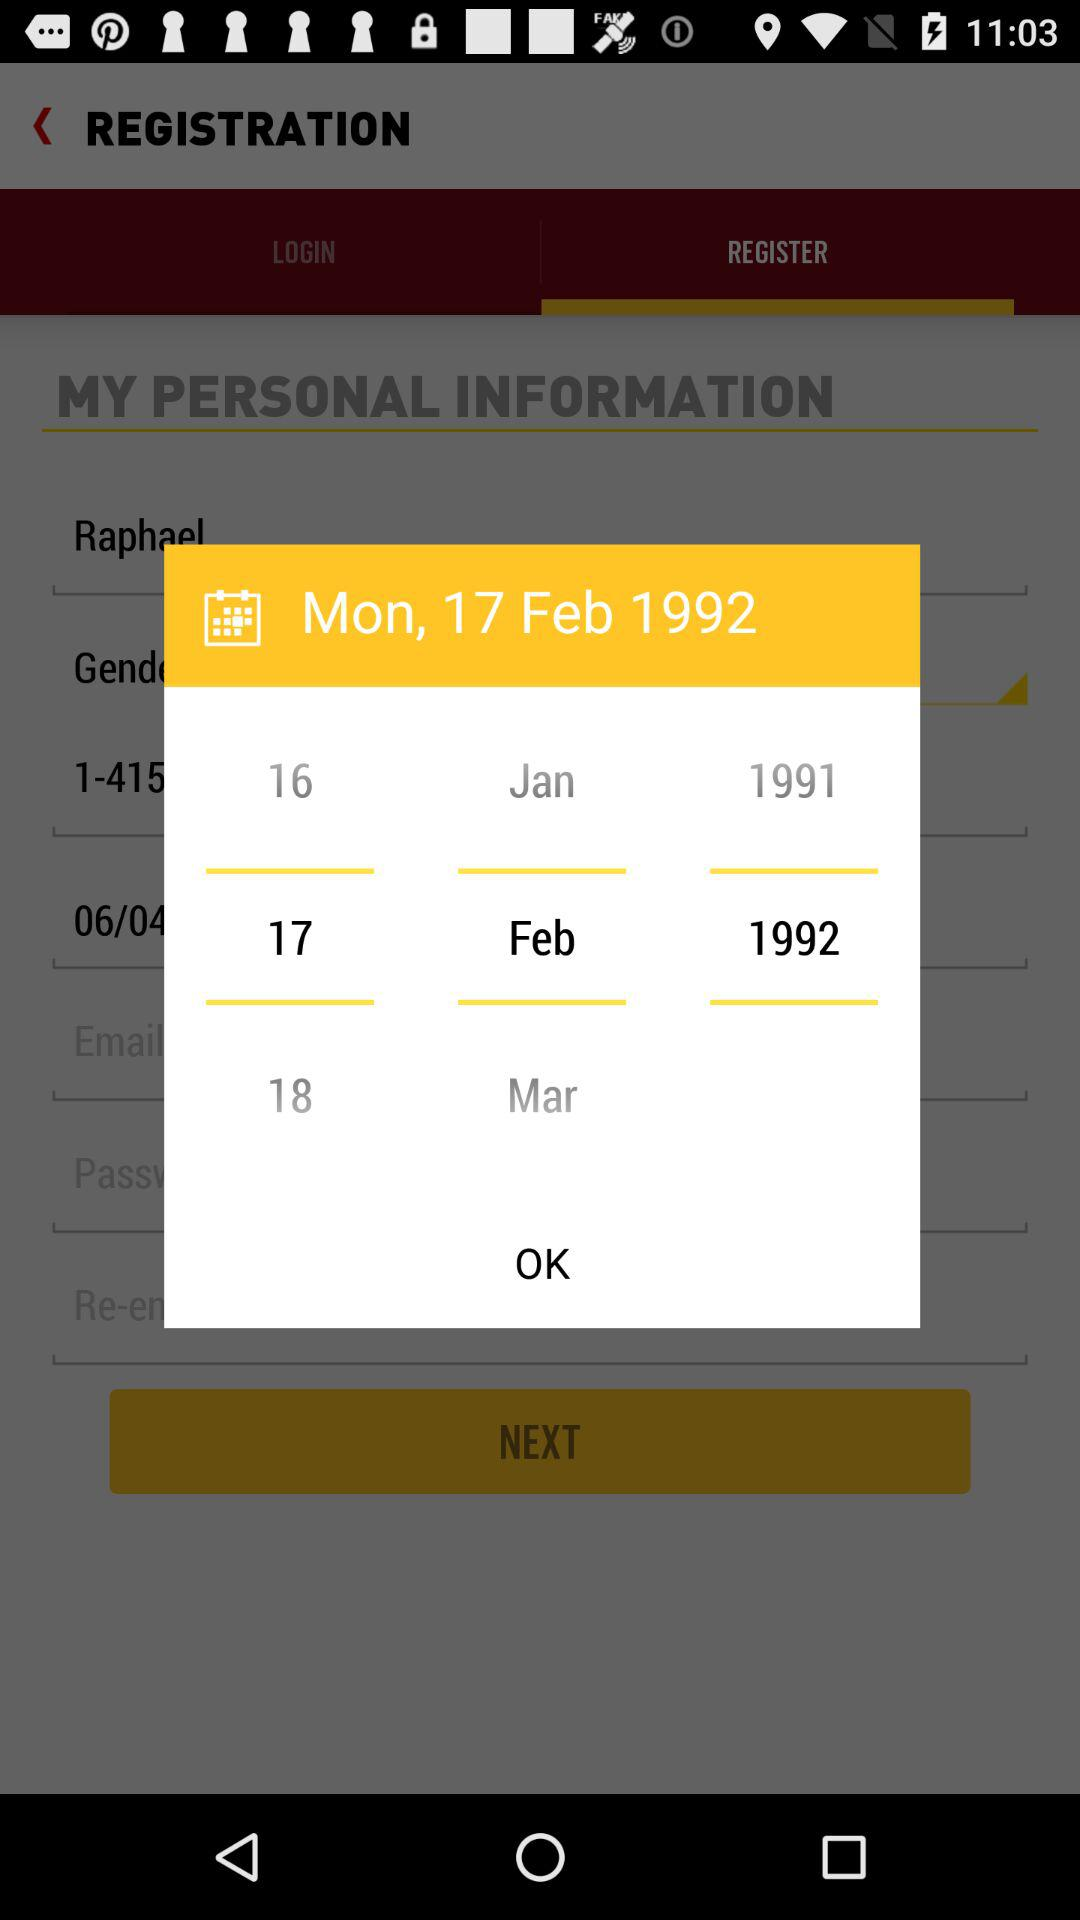How many months are between the first and last date in the calendar?
Answer the question using a single word or phrase. 2 